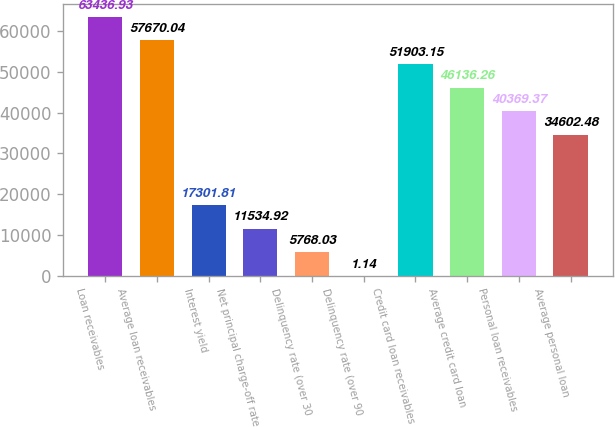Convert chart to OTSL. <chart><loc_0><loc_0><loc_500><loc_500><bar_chart><fcel>Loan receivables<fcel>Average loan receivables<fcel>Interest yield<fcel>Net principal charge-off rate<fcel>Delinquency rate (over 30<fcel>Delinquency rate (over 90<fcel>Credit card loan receivables<fcel>Average credit card loan<fcel>Personal loan receivables<fcel>Average personal loan<nl><fcel>63436.9<fcel>57670<fcel>17301.8<fcel>11534.9<fcel>5768.03<fcel>1.14<fcel>51903.2<fcel>46136.3<fcel>40369.4<fcel>34602.5<nl></chart> 